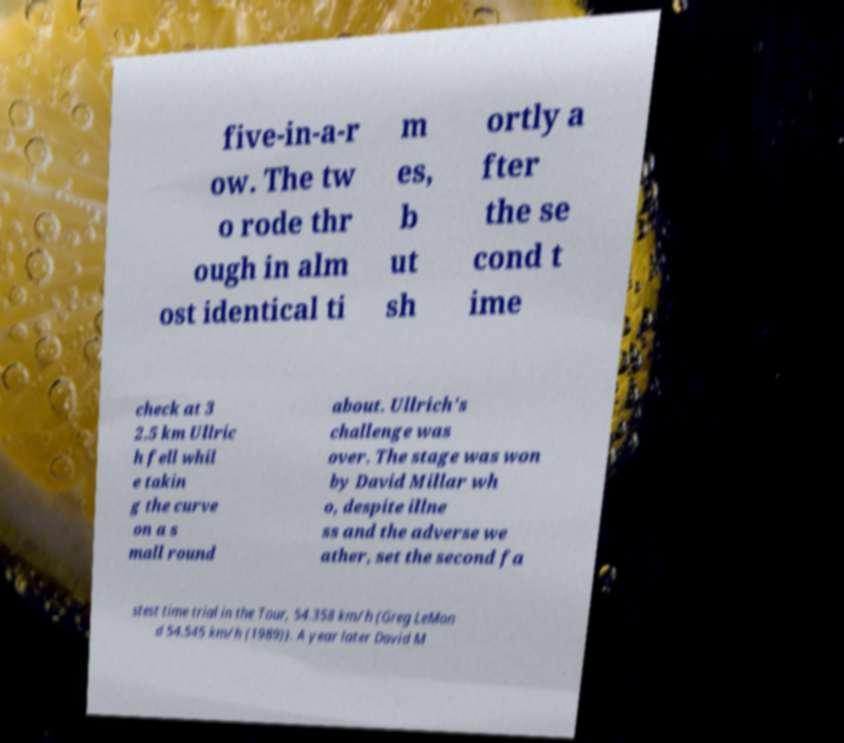Can you accurately transcribe the text from the provided image for me? five-in-a-r ow. The tw o rode thr ough in alm ost identical ti m es, b ut sh ortly a fter the se cond t ime check at 3 2.5 km Ullric h fell whil e takin g the curve on a s mall round about. Ullrich's challenge was over. The stage was won by David Millar wh o, despite illne ss and the adverse we ather, set the second fa stest time trial in the Tour, 54.358 km/h (Greg LeMon d 54.545 km/h (1989)). A year later David M 